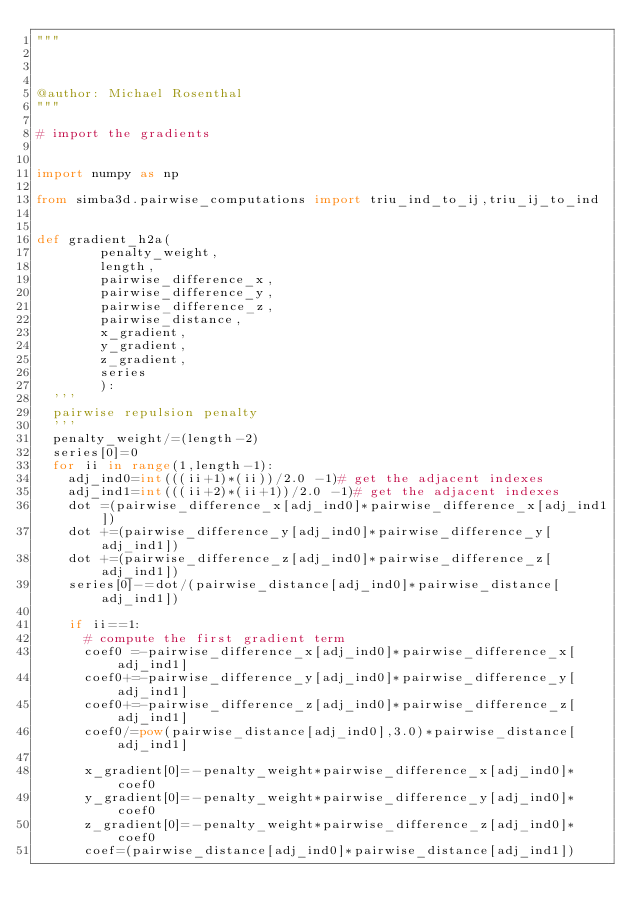Convert code to text. <code><loc_0><loc_0><loc_500><loc_500><_Python_>"""



@author: Michael Rosenthal
"""

# import the gradients


import numpy as np

from simba3d.pairwise_computations import triu_ind_to_ij,triu_ij_to_ind


def gradient_h2a(
				penalty_weight,
				length,
				pairwise_difference_x,
				pairwise_difference_y,
				pairwise_difference_z,
				pairwise_distance,
				x_gradient,
				y_gradient,
				z_gradient,
				series
				):
	'''
	pairwise repulsion penalty
	'''
	penalty_weight/=(length-2)
	series[0]=0
	for ii in range(1,length-1):
		adj_ind0=int(((ii+1)*(ii))/2.0 -1)# get the adjacent indexes
		adj_ind1=int(((ii+2)*(ii+1))/2.0 -1)# get the adjacent indexes
		dot =(pairwise_difference_x[adj_ind0]*pairwise_difference_x[adj_ind1])
		dot +=(pairwise_difference_y[adj_ind0]*pairwise_difference_y[adj_ind1])
		dot +=(pairwise_difference_z[adj_ind0]*pairwise_difference_z[adj_ind1])
		series[0]-=dot/(pairwise_distance[adj_ind0]*pairwise_distance[adj_ind1])

		if ii==1:
			# compute the first gradient term
			coef0 =-pairwise_difference_x[adj_ind0]*pairwise_difference_x[adj_ind1]
			coef0+=-pairwise_difference_y[adj_ind0]*pairwise_difference_y[adj_ind1]
			coef0+=-pairwise_difference_z[adj_ind0]*pairwise_difference_z[adj_ind1]
			coef0/=pow(pairwise_distance[adj_ind0],3.0)*pairwise_distance[adj_ind1]		

			x_gradient[0]=-penalty_weight*pairwise_difference_x[adj_ind0]*coef0
			y_gradient[0]=-penalty_weight*pairwise_difference_y[adj_ind0]*coef0
			z_gradient[0]=-penalty_weight*pairwise_difference_z[adj_ind0]*coef0
			coef=(pairwise_distance[adj_ind0]*pairwise_distance[adj_ind1])
</code> 